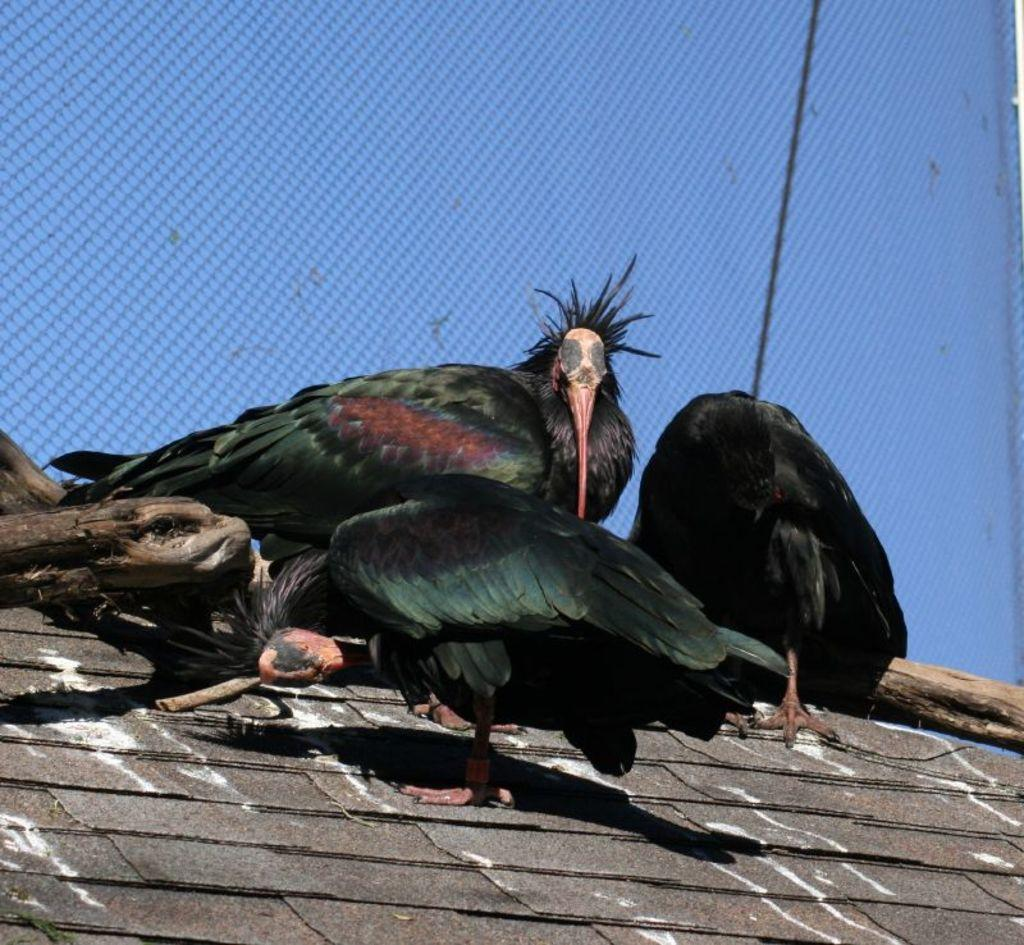What type of animals can be seen in the image? There are birds in the image. What objects are on the platform in the image? There are sticks on a platform in the image. What color is the background of the image? The background of the image is blue. What type of mountain can be seen in the background of the image? There is no mountain present in the image; the background is blue. What season is depicted in the image, given the presence of summer activities? There is no indication of a specific season or any summer activities in the image. 